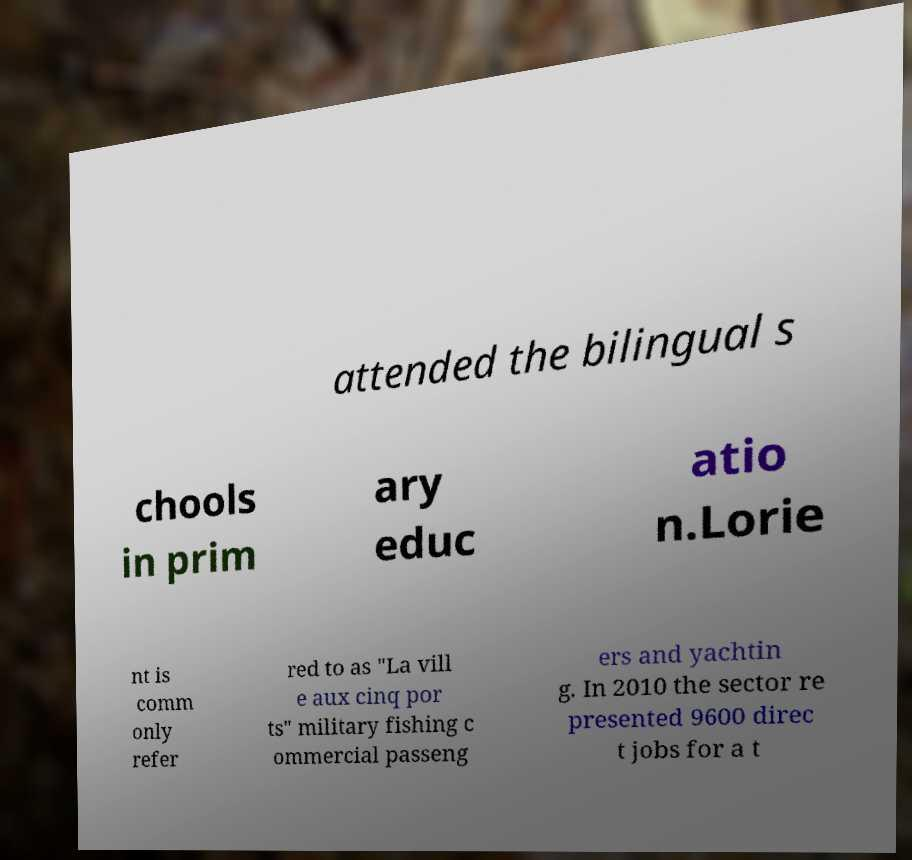Please read and relay the text visible in this image. What does it say? attended the bilingual s chools in prim ary educ atio n.Lorie nt is comm only refer red to as "La vill e aux cinq por ts" military fishing c ommercial passeng ers and yachtin g. In 2010 the sector re presented 9600 direc t jobs for a t 